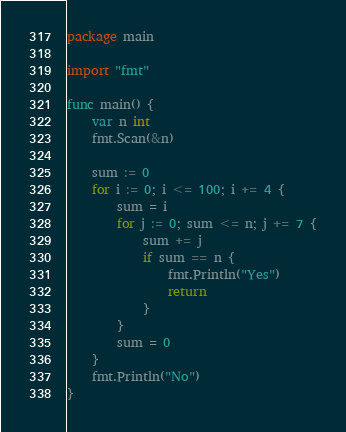Convert code to text. <code><loc_0><loc_0><loc_500><loc_500><_Go_>package main

import "fmt"

func main() {
	var n int
	fmt.Scan(&n)

	sum := 0
	for i := 0; i <= 100; i += 4 {
		sum = i
		for j := 0; sum <= n; j += 7 {
			sum += j
			if sum == n {
				fmt.Println("Yes")
				return
			}
		}
		sum = 0
	}
	fmt.Println("No")
}
</code> 